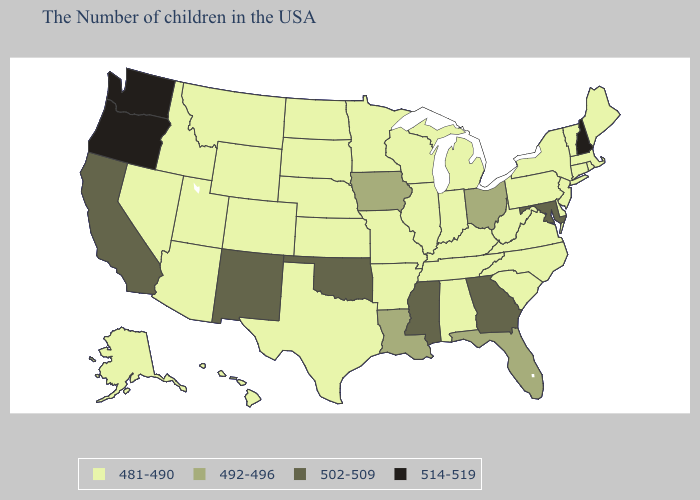Does the first symbol in the legend represent the smallest category?
Be succinct. Yes. What is the highest value in the USA?
Concise answer only. 514-519. Does Oregon have the lowest value in the West?
Give a very brief answer. No. What is the value of North Dakota?
Be succinct. 481-490. What is the value of Missouri?
Give a very brief answer. 481-490. What is the value of North Carolina?
Short answer required. 481-490. Name the states that have a value in the range 502-509?
Concise answer only. Maryland, Georgia, Mississippi, Oklahoma, New Mexico, California. Among the states that border Florida , does Georgia have the lowest value?
Answer briefly. No. What is the highest value in the West ?
Short answer required. 514-519. Among the states that border Ohio , which have the highest value?
Concise answer only. Pennsylvania, West Virginia, Michigan, Kentucky, Indiana. Does the map have missing data?
Concise answer only. No. What is the value of West Virginia?
Give a very brief answer. 481-490. What is the value of Nevada?
Be succinct. 481-490. Name the states that have a value in the range 492-496?
Write a very short answer. Ohio, Florida, Louisiana, Iowa. What is the value of Arizona?
Answer briefly. 481-490. 